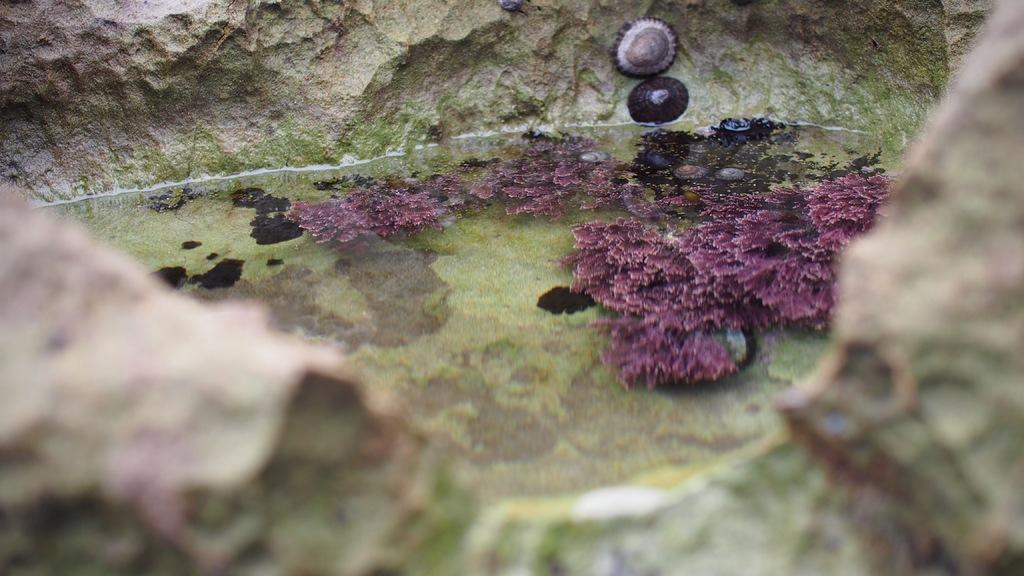What is the primary element present in the image? There is water in the image. What type of plants can be seen in the image? There are aquatic plants in the image. What other object is visible in the image? There is a rock in the image. What is the voice of the playground equipment in the image? There is no playground equipment present in the image, so there is no voice to describe. 